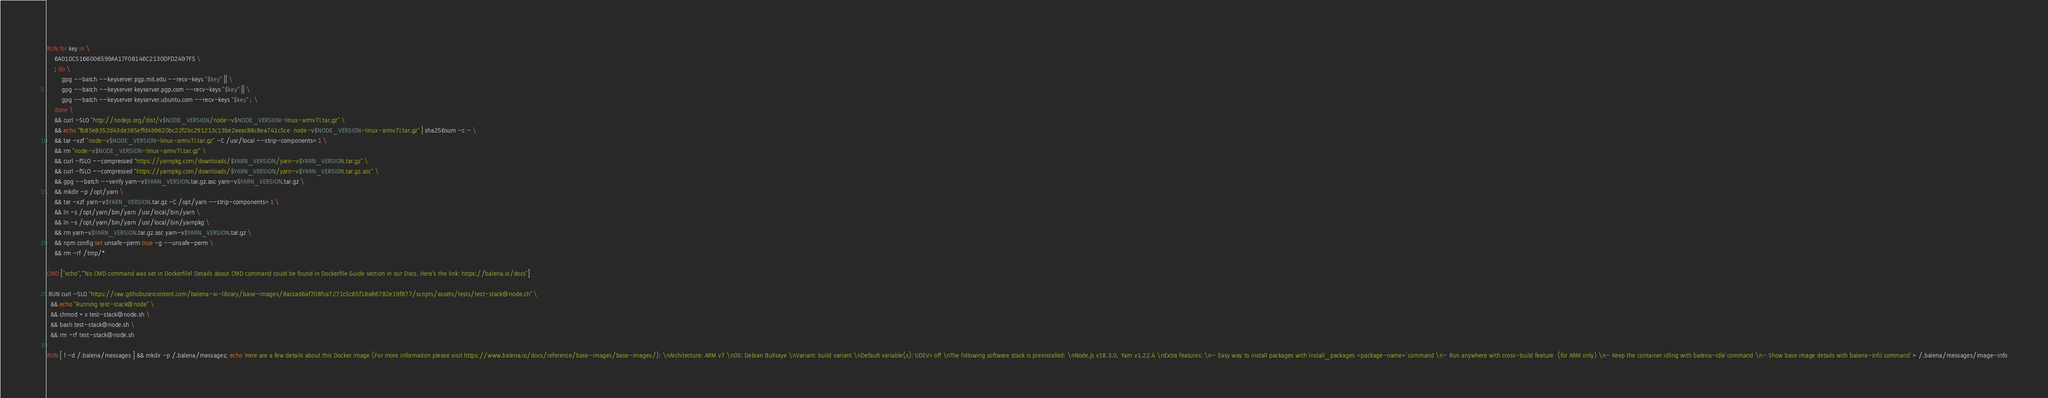<code> <loc_0><loc_0><loc_500><loc_500><_Dockerfile_>RUN for key in \
	6A010C5166006599AA17F08146C2130DFD2497F5 \
	; do \
		gpg --batch --keyserver pgp.mit.edu --recv-keys "$key" || \
		gpg --batch --keyserver keyserver.pgp.com --recv-keys "$key" || \
		gpg --batch --keyserver keyserver.ubuntu.com --recv-keys "$key" ; \
	done \
	&& curl -SLO "http://nodejs.org/dist/v$NODE_VERSION/node-v$NODE_VERSION-linux-armv7l.tar.gz" \
	&& echo "fb85e8352d43de365effd4b9620bc22f2bc291213c13be2aeac88c8ea741c5ce  node-v$NODE_VERSION-linux-armv7l.tar.gz" | sha256sum -c - \
	&& tar -xzf "node-v$NODE_VERSION-linux-armv7l.tar.gz" -C /usr/local --strip-components=1 \
	&& rm "node-v$NODE_VERSION-linux-armv7l.tar.gz" \
	&& curl -fSLO --compressed "https://yarnpkg.com/downloads/$YARN_VERSION/yarn-v$YARN_VERSION.tar.gz" \
	&& curl -fSLO --compressed "https://yarnpkg.com/downloads/$YARN_VERSION/yarn-v$YARN_VERSION.tar.gz.asc" \
	&& gpg --batch --verify yarn-v$YARN_VERSION.tar.gz.asc yarn-v$YARN_VERSION.tar.gz \
	&& mkdir -p /opt/yarn \
	&& tar -xzf yarn-v$YARN_VERSION.tar.gz -C /opt/yarn --strip-components=1 \
	&& ln -s /opt/yarn/bin/yarn /usr/local/bin/yarn \
	&& ln -s /opt/yarn/bin/yarn /usr/local/bin/yarnpkg \
	&& rm yarn-v$YARN_VERSION.tar.gz.asc yarn-v$YARN_VERSION.tar.gz \
	&& npm config set unsafe-perm true -g --unsafe-perm \
	&& rm -rf /tmp/*

CMD ["echo","'No CMD command was set in Dockerfile! Details about CMD command could be found in Dockerfile Guide section in our Docs. Here's the link: https://balena.io/docs"]

 RUN curl -SLO "https://raw.githubusercontent.com/balena-io-library/base-images/8accad6af708fca7271c5c65f18a86782e19f877/scripts/assets/tests/test-stack@node.sh" \
  && echo "Running test-stack@node" \
  && chmod +x test-stack@node.sh \
  && bash test-stack@node.sh \
  && rm -rf test-stack@node.sh 

RUN [ ! -d /.balena/messages ] && mkdir -p /.balena/messages; echo 'Here are a few details about this Docker image (For more information please visit https://www.balena.io/docs/reference/base-images/base-images/): \nArchitecture: ARM v7 \nOS: Debian Bullseye \nVariant: build variant \nDefault variable(s): UDEV=off \nThe following software stack is preinstalled: \nNode.js v18.3.0, Yarn v1.22.4 \nExtra features: \n- Easy way to install packages with `install_packages <package-name>` command \n- Run anywhere with cross-build feature  (for ARM only) \n- Keep the container idling with `balena-idle` command \n- Show base image details with `balena-info` command' > /.balena/messages/image-info</code> 